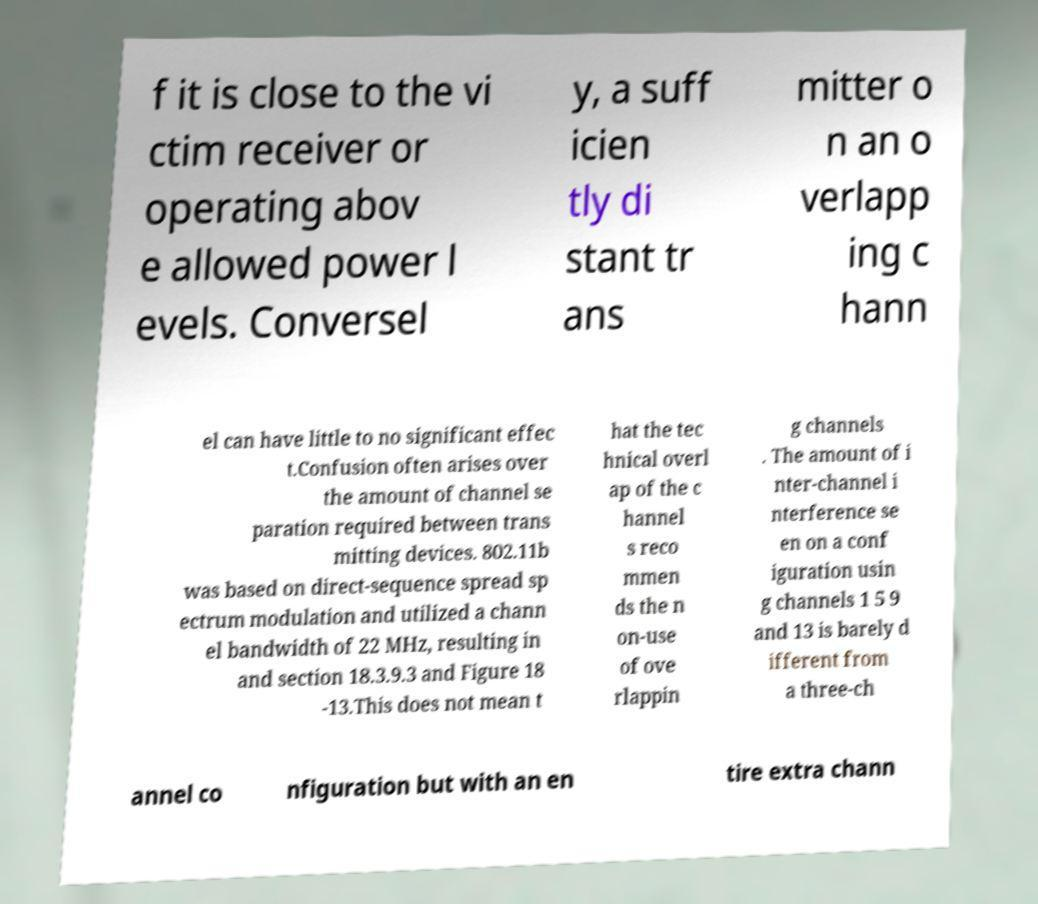Please identify and transcribe the text found in this image. f it is close to the vi ctim receiver or operating abov e allowed power l evels. Conversel y, a suff icien tly di stant tr ans mitter o n an o verlapp ing c hann el can have little to no significant effec t.Confusion often arises over the amount of channel se paration required between trans mitting devices. 802.11b was based on direct-sequence spread sp ectrum modulation and utilized a chann el bandwidth of 22 MHz, resulting in and section 18.3.9.3 and Figure 18 -13.This does not mean t hat the tec hnical overl ap of the c hannel s reco mmen ds the n on-use of ove rlappin g channels . The amount of i nter-channel i nterference se en on a conf iguration usin g channels 1 5 9 and 13 is barely d ifferent from a three-ch annel co nfiguration but with an en tire extra chann 